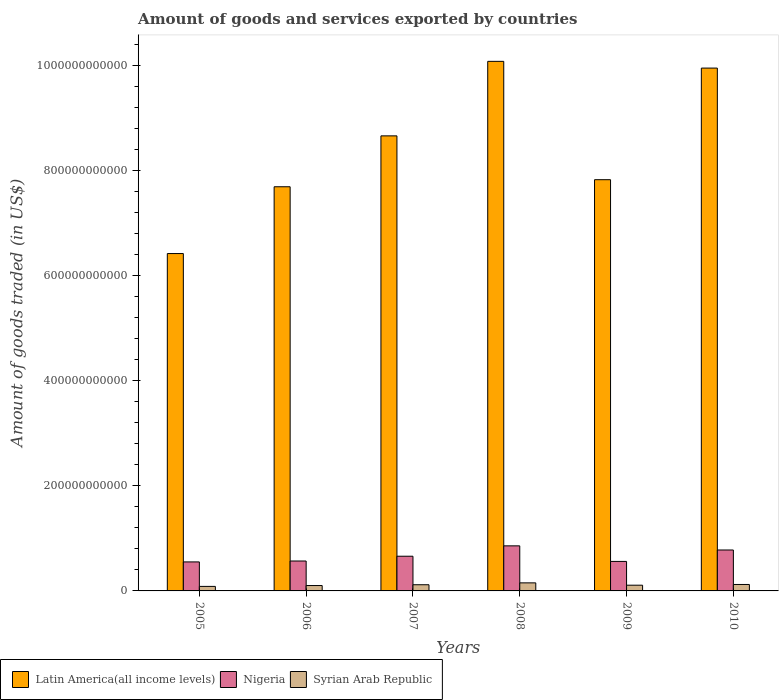How many different coloured bars are there?
Offer a very short reply. 3. Are the number of bars on each tick of the X-axis equal?
Offer a terse response. Yes. How many bars are there on the 2nd tick from the right?
Ensure brevity in your answer.  3. In how many cases, is the number of bars for a given year not equal to the number of legend labels?
Your answer should be compact. 0. What is the total amount of goods and services exported in Latin America(all income levels) in 2006?
Provide a succinct answer. 7.69e+11. Across all years, what is the maximum total amount of goods and services exported in Latin America(all income levels)?
Offer a terse response. 1.01e+12. Across all years, what is the minimum total amount of goods and services exported in Latin America(all income levels)?
Your answer should be very brief. 6.42e+11. In which year was the total amount of goods and services exported in Nigeria minimum?
Give a very brief answer. 2005. What is the total total amount of goods and services exported in Syrian Arab Republic in the graph?
Ensure brevity in your answer.  6.91e+1. What is the difference between the total amount of goods and services exported in Syrian Arab Republic in 2008 and that in 2009?
Provide a succinct answer. 4.45e+09. What is the difference between the total amount of goods and services exported in Nigeria in 2009 and the total amount of goods and services exported in Latin America(all income levels) in 2006?
Make the answer very short. -7.13e+11. What is the average total amount of goods and services exported in Latin America(all income levels) per year?
Give a very brief answer. 8.44e+11. In the year 2006, what is the difference between the total amount of goods and services exported in Syrian Arab Republic and total amount of goods and services exported in Nigeria?
Your response must be concise. -4.67e+1. What is the ratio of the total amount of goods and services exported in Syrian Arab Republic in 2009 to that in 2010?
Your answer should be compact. 0.89. Is the difference between the total amount of goods and services exported in Syrian Arab Republic in 2007 and 2008 greater than the difference between the total amount of goods and services exported in Nigeria in 2007 and 2008?
Ensure brevity in your answer.  Yes. What is the difference between the highest and the second highest total amount of goods and services exported in Syrian Arab Republic?
Offer a terse response. 3.06e+09. What is the difference between the highest and the lowest total amount of goods and services exported in Nigeria?
Offer a very short reply. 3.06e+1. Is the sum of the total amount of goods and services exported in Latin America(all income levels) in 2005 and 2008 greater than the maximum total amount of goods and services exported in Nigeria across all years?
Ensure brevity in your answer.  Yes. What does the 2nd bar from the left in 2005 represents?
Offer a terse response. Nigeria. What does the 1st bar from the right in 2006 represents?
Your answer should be compact. Syrian Arab Republic. Is it the case that in every year, the sum of the total amount of goods and services exported in Latin America(all income levels) and total amount of goods and services exported in Syrian Arab Republic is greater than the total amount of goods and services exported in Nigeria?
Provide a succinct answer. Yes. How many bars are there?
Your answer should be compact. 18. Are all the bars in the graph horizontal?
Keep it short and to the point. No. What is the difference between two consecutive major ticks on the Y-axis?
Provide a succinct answer. 2.00e+11. Are the values on the major ticks of Y-axis written in scientific E-notation?
Offer a terse response. No. Does the graph contain grids?
Give a very brief answer. No. Where does the legend appear in the graph?
Your response must be concise. Bottom left. How are the legend labels stacked?
Keep it short and to the point. Horizontal. What is the title of the graph?
Provide a short and direct response. Amount of goods and services exported by countries. What is the label or title of the X-axis?
Your answer should be compact. Years. What is the label or title of the Y-axis?
Keep it short and to the point. Amount of goods traded (in US$). What is the Amount of goods traded (in US$) of Latin America(all income levels) in 2005?
Your response must be concise. 6.42e+11. What is the Amount of goods traded (in US$) of Nigeria in 2005?
Your answer should be compact. 5.52e+1. What is the Amount of goods traded (in US$) in Syrian Arab Republic in 2005?
Make the answer very short. 8.60e+09. What is the Amount of goods traded (in US$) in Latin America(all income levels) in 2006?
Provide a short and direct response. 7.69e+11. What is the Amount of goods traded (in US$) in Nigeria in 2006?
Make the answer very short. 5.69e+1. What is the Amount of goods traded (in US$) of Syrian Arab Republic in 2006?
Provide a succinct answer. 1.02e+1. What is the Amount of goods traded (in US$) in Latin America(all income levels) in 2007?
Provide a short and direct response. 8.66e+11. What is the Amount of goods traded (in US$) in Nigeria in 2007?
Ensure brevity in your answer.  6.60e+1. What is the Amount of goods traded (in US$) in Syrian Arab Republic in 2007?
Offer a very short reply. 1.18e+1. What is the Amount of goods traded (in US$) of Latin America(all income levels) in 2008?
Provide a succinct answer. 1.01e+12. What is the Amount of goods traded (in US$) in Nigeria in 2008?
Offer a terse response. 8.58e+1. What is the Amount of goods traded (in US$) of Syrian Arab Republic in 2008?
Give a very brief answer. 1.53e+1. What is the Amount of goods traded (in US$) of Latin America(all income levels) in 2009?
Provide a short and direct response. 7.83e+11. What is the Amount of goods traded (in US$) in Nigeria in 2009?
Your answer should be very brief. 5.62e+1. What is the Amount of goods traded (in US$) of Syrian Arab Republic in 2009?
Keep it short and to the point. 1.09e+1. What is the Amount of goods traded (in US$) in Latin America(all income levels) in 2010?
Provide a short and direct response. 9.95e+11. What is the Amount of goods traded (in US$) in Nigeria in 2010?
Offer a very short reply. 7.79e+1. What is the Amount of goods traded (in US$) in Syrian Arab Republic in 2010?
Provide a short and direct response. 1.23e+1. Across all years, what is the maximum Amount of goods traded (in US$) of Latin America(all income levels)?
Provide a succinct answer. 1.01e+12. Across all years, what is the maximum Amount of goods traded (in US$) of Nigeria?
Offer a very short reply. 8.58e+1. Across all years, what is the maximum Amount of goods traded (in US$) in Syrian Arab Republic?
Your response must be concise. 1.53e+1. Across all years, what is the minimum Amount of goods traded (in US$) of Latin America(all income levels)?
Provide a short and direct response. 6.42e+11. Across all years, what is the minimum Amount of goods traded (in US$) of Nigeria?
Provide a short and direct response. 5.52e+1. Across all years, what is the minimum Amount of goods traded (in US$) in Syrian Arab Republic?
Keep it short and to the point. 8.60e+09. What is the total Amount of goods traded (in US$) in Latin America(all income levels) in the graph?
Give a very brief answer. 5.06e+12. What is the total Amount of goods traded (in US$) of Nigeria in the graph?
Your response must be concise. 3.98e+11. What is the total Amount of goods traded (in US$) in Syrian Arab Republic in the graph?
Keep it short and to the point. 6.91e+1. What is the difference between the Amount of goods traded (in US$) in Latin America(all income levels) in 2005 and that in 2006?
Provide a succinct answer. -1.27e+11. What is the difference between the Amount of goods traded (in US$) of Nigeria in 2005 and that in 2006?
Provide a short and direct response. -1.73e+09. What is the difference between the Amount of goods traded (in US$) of Syrian Arab Republic in 2005 and that in 2006?
Ensure brevity in your answer.  -1.64e+09. What is the difference between the Amount of goods traded (in US$) of Latin America(all income levels) in 2005 and that in 2007?
Keep it short and to the point. -2.24e+11. What is the difference between the Amount of goods traded (in US$) in Nigeria in 2005 and that in 2007?
Ensure brevity in your answer.  -1.08e+1. What is the difference between the Amount of goods traded (in US$) in Syrian Arab Republic in 2005 and that in 2007?
Provide a short and direct response. -3.15e+09. What is the difference between the Amount of goods traded (in US$) of Latin America(all income levels) in 2005 and that in 2008?
Give a very brief answer. -3.66e+11. What is the difference between the Amount of goods traded (in US$) in Nigeria in 2005 and that in 2008?
Make the answer very short. -3.06e+1. What is the difference between the Amount of goods traded (in US$) of Syrian Arab Republic in 2005 and that in 2008?
Provide a succinct answer. -6.73e+09. What is the difference between the Amount of goods traded (in US$) in Latin America(all income levels) in 2005 and that in 2009?
Your answer should be very brief. -1.41e+11. What is the difference between the Amount of goods traded (in US$) of Nigeria in 2005 and that in 2009?
Give a very brief answer. -9.66e+08. What is the difference between the Amount of goods traded (in US$) in Syrian Arab Republic in 2005 and that in 2009?
Your answer should be very brief. -2.28e+09. What is the difference between the Amount of goods traded (in US$) in Latin America(all income levels) in 2005 and that in 2010?
Provide a succinct answer. -3.53e+11. What is the difference between the Amount of goods traded (in US$) of Nigeria in 2005 and that in 2010?
Your answer should be very brief. -2.27e+1. What is the difference between the Amount of goods traded (in US$) of Syrian Arab Republic in 2005 and that in 2010?
Ensure brevity in your answer.  -3.67e+09. What is the difference between the Amount of goods traded (in US$) in Latin America(all income levels) in 2006 and that in 2007?
Ensure brevity in your answer.  -9.68e+1. What is the difference between the Amount of goods traded (in US$) in Nigeria in 2006 and that in 2007?
Your answer should be very brief. -9.10e+09. What is the difference between the Amount of goods traded (in US$) of Syrian Arab Republic in 2006 and that in 2007?
Your response must be concise. -1.51e+09. What is the difference between the Amount of goods traded (in US$) of Latin America(all income levels) in 2006 and that in 2008?
Keep it short and to the point. -2.39e+11. What is the difference between the Amount of goods traded (in US$) of Nigeria in 2006 and that in 2008?
Make the answer very short. -2.88e+1. What is the difference between the Amount of goods traded (in US$) of Syrian Arab Republic in 2006 and that in 2008?
Give a very brief answer. -5.09e+09. What is the difference between the Amount of goods traded (in US$) in Latin America(all income levels) in 2006 and that in 2009?
Make the answer very short. -1.35e+1. What is the difference between the Amount of goods traded (in US$) in Nigeria in 2006 and that in 2009?
Your answer should be very brief. 7.68e+08. What is the difference between the Amount of goods traded (in US$) in Syrian Arab Republic in 2006 and that in 2009?
Your response must be concise. -6.39e+08. What is the difference between the Amount of goods traded (in US$) in Latin America(all income levels) in 2006 and that in 2010?
Your answer should be compact. -2.26e+11. What is the difference between the Amount of goods traded (in US$) in Nigeria in 2006 and that in 2010?
Keep it short and to the point. -2.09e+1. What is the difference between the Amount of goods traded (in US$) of Syrian Arab Republic in 2006 and that in 2010?
Offer a terse response. -2.03e+09. What is the difference between the Amount of goods traded (in US$) of Latin America(all income levels) in 2007 and that in 2008?
Your response must be concise. -1.42e+11. What is the difference between the Amount of goods traded (in US$) in Nigeria in 2007 and that in 2008?
Keep it short and to the point. -1.97e+1. What is the difference between the Amount of goods traded (in US$) of Syrian Arab Republic in 2007 and that in 2008?
Provide a short and direct response. -3.58e+09. What is the difference between the Amount of goods traded (in US$) in Latin America(all income levels) in 2007 and that in 2009?
Make the answer very short. 8.34e+1. What is the difference between the Amount of goods traded (in US$) of Nigeria in 2007 and that in 2009?
Make the answer very short. 9.87e+09. What is the difference between the Amount of goods traded (in US$) in Syrian Arab Republic in 2007 and that in 2009?
Keep it short and to the point. 8.72e+08. What is the difference between the Amount of goods traded (in US$) of Latin America(all income levels) in 2007 and that in 2010?
Make the answer very short. -1.29e+11. What is the difference between the Amount of goods traded (in US$) in Nigeria in 2007 and that in 2010?
Make the answer very short. -1.18e+1. What is the difference between the Amount of goods traded (in US$) in Syrian Arab Republic in 2007 and that in 2010?
Provide a succinct answer. -5.17e+08. What is the difference between the Amount of goods traded (in US$) in Latin America(all income levels) in 2008 and that in 2009?
Keep it short and to the point. 2.25e+11. What is the difference between the Amount of goods traded (in US$) in Nigeria in 2008 and that in 2009?
Offer a terse response. 2.96e+1. What is the difference between the Amount of goods traded (in US$) in Syrian Arab Republic in 2008 and that in 2009?
Provide a short and direct response. 4.45e+09. What is the difference between the Amount of goods traded (in US$) of Latin America(all income levels) in 2008 and that in 2010?
Offer a very short reply. 1.28e+1. What is the difference between the Amount of goods traded (in US$) in Nigeria in 2008 and that in 2010?
Provide a succinct answer. 7.89e+09. What is the difference between the Amount of goods traded (in US$) of Syrian Arab Republic in 2008 and that in 2010?
Your response must be concise. 3.06e+09. What is the difference between the Amount of goods traded (in US$) of Latin America(all income levels) in 2009 and that in 2010?
Ensure brevity in your answer.  -2.12e+11. What is the difference between the Amount of goods traded (in US$) of Nigeria in 2009 and that in 2010?
Make the answer very short. -2.17e+1. What is the difference between the Amount of goods traded (in US$) of Syrian Arab Republic in 2009 and that in 2010?
Offer a very short reply. -1.39e+09. What is the difference between the Amount of goods traded (in US$) in Latin America(all income levels) in 2005 and the Amount of goods traded (in US$) in Nigeria in 2006?
Provide a succinct answer. 5.85e+11. What is the difference between the Amount of goods traded (in US$) in Latin America(all income levels) in 2005 and the Amount of goods traded (in US$) in Syrian Arab Republic in 2006?
Keep it short and to the point. 6.32e+11. What is the difference between the Amount of goods traded (in US$) of Nigeria in 2005 and the Amount of goods traded (in US$) of Syrian Arab Republic in 2006?
Your answer should be compact. 4.50e+1. What is the difference between the Amount of goods traded (in US$) in Latin America(all income levels) in 2005 and the Amount of goods traded (in US$) in Nigeria in 2007?
Keep it short and to the point. 5.76e+11. What is the difference between the Amount of goods traded (in US$) of Latin America(all income levels) in 2005 and the Amount of goods traded (in US$) of Syrian Arab Republic in 2007?
Give a very brief answer. 6.30e+11. What is the difference between the Amount of goods traded (in US$) in Nigeria in 2005 and the Amount of goods traded (in US$) in Syrian Arab Republic in 2007?
Make the answer very short. 4.34e+1. What is the difference between the Amount of goods traded (in US$) of Latin America(all income levels) in 2005 and the Amount of goods traded (in US$) of Nigeria in 2008?
Your answer should be very brief. 5.56e+11. What is the difference between the Amount of goods traded (in US$) of Latin America(all income levels) in 2005 and the Amount of goods traded (in US$) of Syrian Arab Republic in 2008?
Your answer should be compact. 6.27e+11. What is the difference between the Amount of goods traded (in US$) in Nigeria in 2005 and the Amount of goods traded (in US$) in Syrian Arab Republic in 2008?
Offer a very short reply. 3.99e+1. What is the difference between the Amount of goods traded (in US$) of Latin America(all income levels) in 2005 and the Amount of goods traded (in US$) of Nigeria in 2009?
Make the answer very short. 5.86e+11. What is the difference between the Amount of goods traded (in US$) in Latin America(all income levels) in 2005 and the Amount of goods traded (in US$) in Syrian Arab Republic in 2009?
Give a very brief answer. 6.31e+11. What is the difference between the Amount of goods traded (in US$) in Nigeria in 2005 and the Amount of goods traded (in US$) in Syrian Arab Republic in 2009?
Offer a terse response. 4.43e+1. What is the difference between the Amount of goods traded (in US$) of Latin America(all income levels) in 2005 and the Amount of goods traded (in US$) of Nigeria in 2010?
Ensure brevity in your answer.  5.64e+11. What is the difference between the Amount of goods traded (in US$) in Latin America(all income levels) in 2005 and the Amount of goods traded (in US$) in Syrian Arab Republic in 2010?
Keep it short and to the point. 6.30e+11. What is the difference between the Amount of goods traded (in US$) of Nigeria in 2005 and the Amount of goods traded (in US$) of Syrian Arab Republic in 2010?
Make the answer very short. 4.29e+1. What is the difference between the Amount of goods traded (in US$) of Latin America(all income levels) in 2006 and the Amount of goods traded (in US$) of Nigeria in 2007?
Your answer should be very brief. 7.03e+11. What is the difference between the Amount of goods traded (in US$) in Latin America(all income levels) in 2006 and the Amount of goods traded (in US$) in Syrian Arab Republic in 2007?
Offer a terse response. 7.57e+11. What is the difference between the Amount of goods traded (in US$) in Nigeria in 2006 and the Amount of goods traded (in US$) in Syrian Arab Republic in 2007?
Ensure brevity in your answer.  4.52e+1. What is the difference between the Amount of goods traded (in US$) of Latin America(all income levels) in 2006 and the Amount of goods traded (in US$) of Nigeria in 2008?
Your answer should be very brief. 6.83e+11. What is the difference between the Amount of goods traded (in US$) of Latin America(all income levels) in 2006 and the Amount of goods traded (in US$) of Syrian Arab Republic in 2008?
Your answer should be very brief. 7.54e+11. What is the difference between the Amount of goods traded (in US$) in Nigeria in 2006 and the Amount of goods traded (in US$) in Syrian Arab Republic in 2008?
Make the answer very short. 4.16e+1. What is the difference between the Amount of goods traded (in US$) of Latin America(all income levels) in 2006 and the Amount of goods traded (in US$) of Nigeria in 2009?
Provide a succinct answer. 7.13e+11. What is the difference between the Amount of goods traded (in US$) in Latin America(all income levels) in 2006 and the Amount of goods traded (in US$) in Syrian Arab Republic in 2009?
Your answer should be compact. 7.58e+11. What is the difference between the Amount of goods traded (in US$) in Nigeria in 2006 and the Amount of goods traded (in US$) in Syrian Arab Republic in 2009?
Make the answer very short. 4.61e+1. What is the difference between the Amount of goods traded (in US$) in Latin America(all income levels) in 2006 and the Amount of goods traded (in US$) in Nigeria in 2010?
Keep it short and to the point. 6.91e+11. What is the difference between the Amount of goods traded (in US$) in Latin America(all income levels) in 2006 and the Amount of goods traded (in US$) in Syrian Arab Republic in 2010?
Your answer should be very brief. 7.57e+11. What is the difference between the Amount of goods traded (in US$) of Nigeria in 2006 and the Amount of goods traded (in US$) of Syrian Arab Republic in 2010?
Provide a succinct answer. 4.47e+1. What is the difference between the Amount of goods traded (in US$) in Latin America(all income levels) in 2007 and the Amount of goods traded (in US$) in Nigeria in 2008?
Your answer should be compact. 7.80e+11. What is the difference between the Amount of goods traded (in US$) in Latin America(all income levels) in 2007 and the Amount of goods traded (in US$) in Syrian Arab Republic in 2008?
Keep it short and to the point. 8.51e+11. What is the difference between the Amount of goods traded (in US$) in Nigeria in 2007 and the Amount of goods traded (in US$) in Syrian Arab Republic in 2008?
Offer a very short reply. 5.07e+1. What is the difference between the Amount of goods traded (in US$) in Latin America(all income levels) in 2007 and the Amount of goods traded (in US$) in Nigeria in 2009?
Give a very brief answer. 8.10e+11. What is the difference between the Amount of goods traded (in US$) in Latin America(all income levels) in 2007 and the Amount of goods traded (in US$) in Syrian Arab Republic in 2009?
Offer a terse response. 8.55e+11. What is the difference between the Amount of goods traded (in US$) in Nigeria in 2007 and the Amount of goods traded (in US$) in Syrian Arab Republic in 2009?
Your answer should be very brief. 5.52e+1. What is the difference between the Amount of goods traded (in US$) in Latin America(all income levels) in 2007 and the Amount of goods traded (in US$) in Nigeria in 2010?
Provide a short and direct response. 7.88e+11. What is the difference between the Amount of goods traded (in US$) in Latin America(all income levels) in 2007 and the Amount of goods traded (in US$) in Syrian Arab Republic in 2010?
Give a very brief answer. 8.54e+11. What is the difference between the Amount of goods traded (in US$) of Nigeria in 2007 and the Amount of goods traded (in US$) of Syrian Arab Republic in 2010?
Your answer should be compact. 5.38e+1. What is the difference between the Amount of goods traded (in US$) of Latin America(all income levels) in 2008 and the Amount of goods traded (in US$) of Nigeria in 2009?
Your answer should be compact. 9.52e+11. What is the difference between the Amount of goods traded (in US$) in Latin America(all income levels) in 2008 and the Amount of goods traded (in US$) in Syrian Arab Republic in 2009?
Ensure brevity in your answer.  9.97e+11. What is the difference between the Amount of goods traded (in US$) of Nigeria in 2008 and the Amount of goods traded (in US$) of Syrian Arab Republic in 2009?
Keep it short and to the point. 7.49e+1. What is the difference between the Amount of goods traded (in US$) of Latin America(all income levels) in 2008 and the Amount of goods traded (in US$) of Nigeria in 2010?
Offer a terse response. 9.30e+11. What is the difference between the Amount of goods traded (in US$) of Latin America(all income levels) in 2008 and the Amount of goods traded (in US$) of Syrian Arab Republic in 2010?
Give a very brief answer. 9.96e+11. What is the difference between the Amount of goods traded (in US$) of Nigeria in 2008 and the Amount of goods traded (in US$) of Syrian Arab Republic in 2010?
Keep it short and to the point. 7.35e+1. What is the difference between the Amount of goods traded (in US$) of Latin America(all income levels) in 2009 and the Amount of goods traded (in US$) of Nigeria in 2010?
Your response must be concise. 7.05e+11. What is the difference between the Amount of goods traded (in US$) in Latin America(all income levels) in 2009 and the Amount of goods traded (in US$) in Syrian Arab Republic in 2010?
Your response must be concise. 7.70e+11. What is the difference between the Amount of goods traded (in US$) in Nigeria in 2009 and the Amount of goods traded (in US$) in Syrian Arab Republic in 2010?
Offer a very short reply. 4.39e+1. What is the average Amount of goods traded (in US$) in Latin America(all income levels) per year?
Your answer should be very brief. 8.44e+11. What is the average Amount of goods traded (in US$) in Nigeria per year?
Ensure brevity in your answer.  6.63e+1. What is the average Amount of goods traded (in US$) of Syrian Arab Republic per year?
Your response must be concise. 1.15e+1. In the year 2005, what is the difference between the Amount of goods traded (in US$) of Latin America(all income levels) and Amount of goods traded (in US$) of Nigeria?
Provide a succinct answer. 5.87e+11. In the year 2005, what is the difference between the Amount of goods traded (in US$) in Latin America(all income levels) and Amount of goods traded (in US$) in Syrian Arab Republic?
Give a very brief answer. 6.33e+11. In the year 2005, what is the difference between the Amount of goods traded (in US$) of Nigeria and Amount of goods traded (in US$) of Syrian Arab Republic?
Make the answer very short. 4.66e+1. In the year 2006, what is the difference between the Amount of goods traded (in US$) in Latin America(all income levels) and Amount of goods traded (in US$) in Nigeria?
Offer a very short reply. 7.12e+11. In the year 2006, what is the difference between the Amount of goods traded (in US$) in Latin America(all income levels) and Amount of goods traded (in US$) in Syrian Arab Republic?
Keep it short and to the point. 7.59e+11. In the year 2006, what is the difference between the Amount of goods traded (in US$) of Nigeria and Amount of goods traded (in US$) of Syrian Arab Republic?
Offer a terse response. 4.67e+1. In the year 2007, what is the difference between the Amount of goods traded (in US$) in Latin America(all income levels) and Amount of goods traded (in US$) in Nigeria?
Ensure brevity in your answer.  8.00e+11. In the year 2007, what is the difference between the Amount of goods traded (in US$) of Latin America(all income levels) and Amount of goods traded (in US$) of Syrian Arab Republic?
Offer a terse response. 8.54e+11. In the year 2007, what is the difference between the Amount of goods traded (in US$) of Nigeria and Amount of goods traded (in US$) of Syrian Arab Republic?
Provide a succinct answer. 5.43e+1. In the year 2008, what is the difference between the Amount of goods traded (in US$) of Latin America(all income levels) and Amount of goods traded (in US$) of Nigeria?
Offer a terse response. 9.22e+11. In the year 2008, what is the difference between the Amount of goods traded (in US$) in Latin America(all income levels) and Amount of goods traded (in US$) in Syrian Arab Republic?
Your response must be concise. 9.93e+11. In the year 2008, what is the difference between the Amount of goods traded (in US$) in Nigeria and Amount of goods traded (in US$) in Syrian Arab Republic?
Make the answer very short. 7.04e+1. In the year 2009, what is the difference between the Amount of goods traded (in US$) in Latin America(all income levels) and Amount of goods traded (in US$) in Nigeria?
Provide a short and direct response. 7.26e+11. In the year 2009, what is the difference between the Amount of goods traded (in US$) in Latin America(all income levels) and Amount of goods traded (in US$) in Syrian Arab Republic?
Give a very brief answer. 7.72e+11. In the year 2009, what is the difference between the Amount of goods traded (in US$) of Nigeria and Amount of goods traded (in US$) of Syrian Arab Republic?
Keep it short and to the point. 4.53e+1. In the year 2010, what is the difference between the Amount of goods traded (in US$) of Latin America(all income levels) and Amount of goods traded (in US$) of Nigeria?
Your answer should be very brief. 9.17e+11. In the year 2010, what is the difference between the Amount of goods traded (in US$) in Latin America(all income levels) and Amount of goods traded (in US$) in Syrian Arab Republic?
Make the answer very short. 9.83e+11. In the year 2010, what is the difference between the Amount of goods traded (in US$) of Nigeria and Amount of goods traded (in US$) of Syrian Arab Republic?
Provide a short and direct response. 6.56e+1. What is the ratio of the Amount of goods traded (in US$) of Latin America(all income levels) in 2005 to that in 2006?
Keep it short and to the point. 0.83. What is the ratio of the Amount of goods traded (in US$) in Nigeria in 2005 to that in 2006?
Ensure brevity in your answer.  0.97. What is the ratio of the Amount of goods traded (in US$) of Syrian Arab Republic in 2005 to that in 2006?
Ensure brevity in your answer.  0.84. What is the ratio of the Amount of goods traded (in US$) in Latin America(all income levels) in 2005 to that in 2007?
Make the answer very short. 0.74. What is the ratio of the Amount of goods traded (in US$) in Nigeria in 2005 to that in 2007?
Offer a terse response. 0.84. What is the ratio of the Amount of goods traded (in US$) in Syrian Arab Republic in 2005 to that in 2007?
Offer a terse response. 0.73. What is the ratio of the Amount of goods traded (in US$) in Latin America(all income levels) in 2005 to that in 2008?
Offer a very short reply. 0.64. What is the ratio of the Amount of goods traded (in US$) in Nigeria in 2005 to that in 2008?
Ensure brevity in your answer.  0.64. What is the ratio of the Amount of goods traded (in US$) in Syrian Arab Republic in 2005 to that in 2008?
Make the answer very short. 0.56. What is the ratio of the Amount of goods traded (in US$) of Latin America(all income levels) in 2005 to that in 2009?
Make the answer very short. 0.82. What is the ratio of the Amount of goods traded (in US$) in Nigeria in 2005 to that in 2009?
Ensure brevity in your answer.  0.98. What is the ratio of the Amount of goods traded (in US$) in Syrian Arab Republic in 2005 to that in 2009?
Give a very brief answer. 0.79. What is the ratio of the Amount of goods traded (in US$) of Latin America(all income levels) in 2005 to that in 2010?
Offer a very short reply. 0.65. What is the ratio of the Amount of goods traded (in US$) of Nigeria in 2005 to that in 2010?
Give a very brief answer. 0.71. What is the ratio of the Amount of goods traded (in US$) of Syrian Arab Republic in 2005 to that in 2010?
Give a very brief answer. 0.7. What is the ratio of the Amount of goods traded (in US$) of Latin America(all income levels) in 2006 to that in 2007?
Your answer should be compact. 0.89. What is the ratio of the Amount of goods traded (in US$) of Nigeria in 2006 to that in 2007?
Provide a short and direct response. 0.86. What is the ratio of the Amount of goods traded (in US$) in Syrian Arab Republic in 2006 to that in 2007?
Offer a terse response. 0.87. What is the ratio of the Amount of goods traded (in US$) of Latin America(all income levels) in 2006 to that in 2008?
Give a very brief answer. 0.76. What is the ratio of the Amount of goods traded (in US$) in Nigeria in 2006 to that in 2008?
Offer a terse response. 0.66. What is the ratio of the Amount of goods traded (in US$) in Syrian Arab Republic in 2006 to that in 2008?
Your answer should be compact. 0.67. What is the ratio of the Amount of goods traded (in US$) in Latin America(all income levels) in 2006 to that in 2009?
Keep it short and to the point. 0.98. What is the ratio of the Amount of goods traded (in US$) in Nigeria in 2006 to that in 2009?
Provide a succinct answer. 1.01. What is the ratio of the Amount of goods traded (in US$) of Syrian Arab Republic in 2006 to that in 2009?
Your response must be concise. 0.94. What is the ratio of the Amount of goods traded (in US$) in Latin America(all income levels) in 2006 to that in 2010?
Your answer should be compact. 0.77. What is the ratio of the Amount of goods traded (in US$) of Nigeria in 2006 to that in 2010?
Provide a short and direct response. 0.73. What is the ratio of the Amount of goods traded (in US$) in Syrian Arab Republic in 2006 to that in 2010?
Offer a terse response. 0.83. What is the ratio of the Amount of goods traded (in US$) in Latin America(all income levels) in 2007 to that in 2008?
Keep it short and to the point. 0.86. What is the ratio of the Amount of goods traded (in US$) of Nigeria in 2007 to that in 2008?
Give a very brief answer. 0.77. What is the ratio of the Amount of goods traded (in US$) of Syrian Arab Republic in 2007 to that in 2008?
Offer a terse response. 0.77. What is the ratio of the Amount of goods traded (in US$) of Latin America(all income levels) in 2007 to that in 2009?
Your answer should be very brief. 1.11. What is the ratio of the Amount of goods traded (in US$) of Nigeria in 2007 to that in 2009?
Give a very brief answer. 1.18. What is the ratio of the Amount of goods traded (in US$) in Syrian Arab Republic in 2007 to that in 2009?
Offer a very short reply. 1.08. What is the ratio of the Amount of goods traded (in US$) of Latin America(all income levels) in 2007 to that in 2010?
Give a very brief answer. 0.87. What is the ratio of the Amount of goods traded (in US$) in Nigeria in 2007 to that in 2010?
Keep it short and to the point. 0.85. What is the ratio of the Amount of goods traded (in US$) in Syrian Arab Republic in 2007 to that in 2010?
Make the answer very short. 0.96. What is the ratio of the Amount of goods traded (in US$) in Latin America(all income levels) in 2008 to that in 2009?
Make the answer very short. 1.29. What is the ratio of the Amount of goods traded (in US$) of Nigeria in 2008 to that in 2009?
Your answer should be compact. 1.53. What is the ratio of the Amount of goods traded (in US$) in Syrian Arab Republic in 2008 to that in 2009?
Provide a succinct answer. 1.41. What is the ratio of the Amount of goods traded (in US$) of Latin America(all income levels) in 2008 to that in 2010?
Your answer should be compact. 1.01. What is the ratio of the Amount of goods traded (in US$) in Nigeria in 2008 to that in 2010?
Keep it short and to the point. 1.1. What is the ratio of the Amount of goods traded (in US$) of Syrian Arab Republic in 2008 to that in 2010?
Give a very brief answer. 1.25. What is the ratio of the Amount of goods traded (in US$) of Latin America(all income levels) in 2009 to that in 2010?
Offer a terse response. 0.79. What is the ratio of the Amount of goods traded (in US$) in Nigeria in 2009 to that in 2010?
Your answer should be very brief. 0.72. What is the ratio of the Amount of goods traded (in US$) in Syrian Arab Republic in 2009 to that in 2010?
Your answer should be very brief. 0.89. What is the difference between the highest and the second highest Amount of goods traded (in US$) in Latin America(all income levels)?
Your answer should be compact. 1.28e+1. What is the difference between the highest and the second highest Amount of goods traded (in US$) in Nigeria?
Offer a very short reply. 7.89e+09. What is the difference between the highest and the second highest Amount of goods traded (in US$) in Syrian Arab Republic?
Offer a terse response. 3.06e+09. What is the difference between the highest and the lowest Amount of goods traded (in US$) of Latin America(all income levels)?
Your answer should be very brief. 3.66e+11. What is the difference between the highest and the lowest Amount of goods traded (in US$) in Nigeria?
Your answer should be compact. 3.06e+1. What is the difference between the highest and the lowest Amount of goods traded (in US$) of Syrian Arab Republic?
Give a very brief answer. 6.73e+09. 